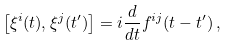Convert formula to latex. <formula><loc_0><loc_0><loc_500><loc_500>\left [ \xi ^ { i } ( t ) , \xi ^ { j } ( t ^ { \prime } ) \right ] = i \frac { d } { d t } f ^ { i j } ( t - t ^ { \prime } ) \, ,</formula> 